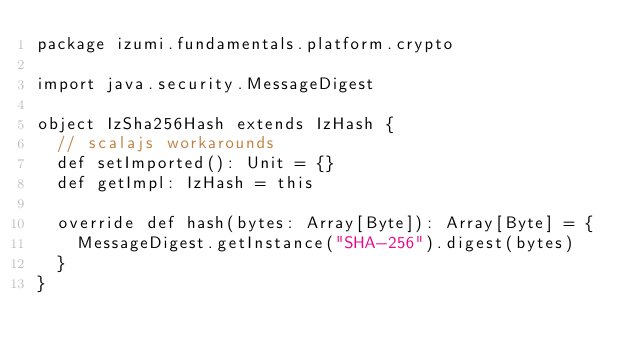Convert code to text. <code><loc_0><loc_0><loc_500><loc_500><_Scala_>package izumi.fundamentals.platform.crypto

import java.security.MessageDigest

object IzSha256Hash extends IzHash {
  // scalajs workarounds
  def setImported(): Unit = {}
  def getImpl: IzHash = this

  override def hash(bytes: Array[Byte]): Array[Byte] = {
    MessageDigest.getInstance("SHA-256").digest(bytes)
  }
}
</code> 